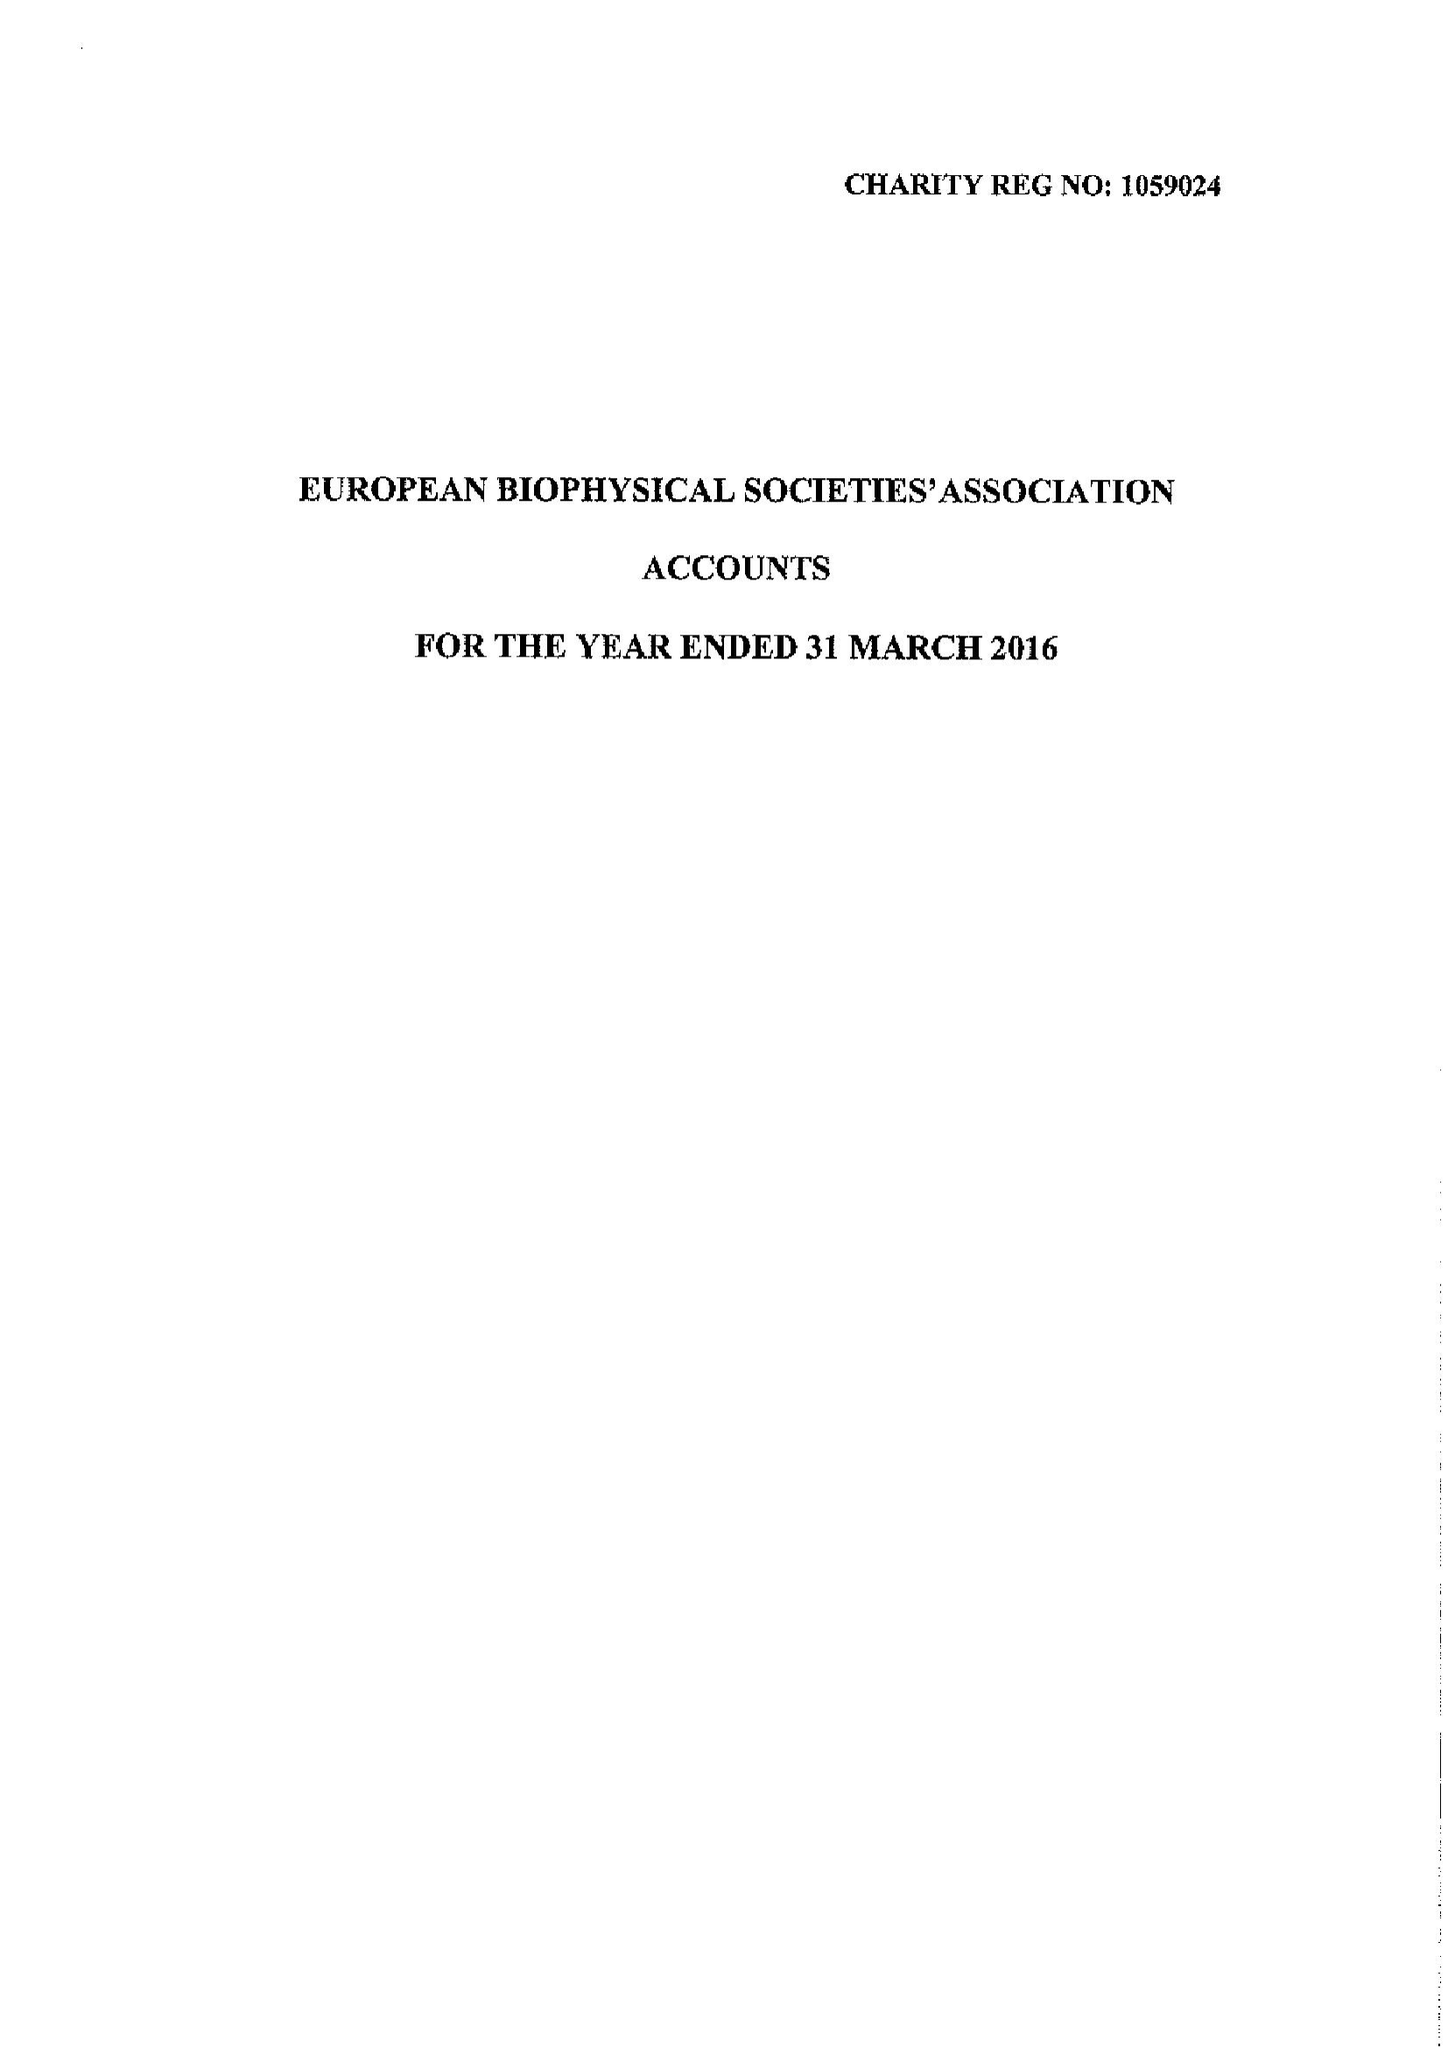What is the value for the address__postcode?
Answer the question using a single word or phrase. YO10 5DD 